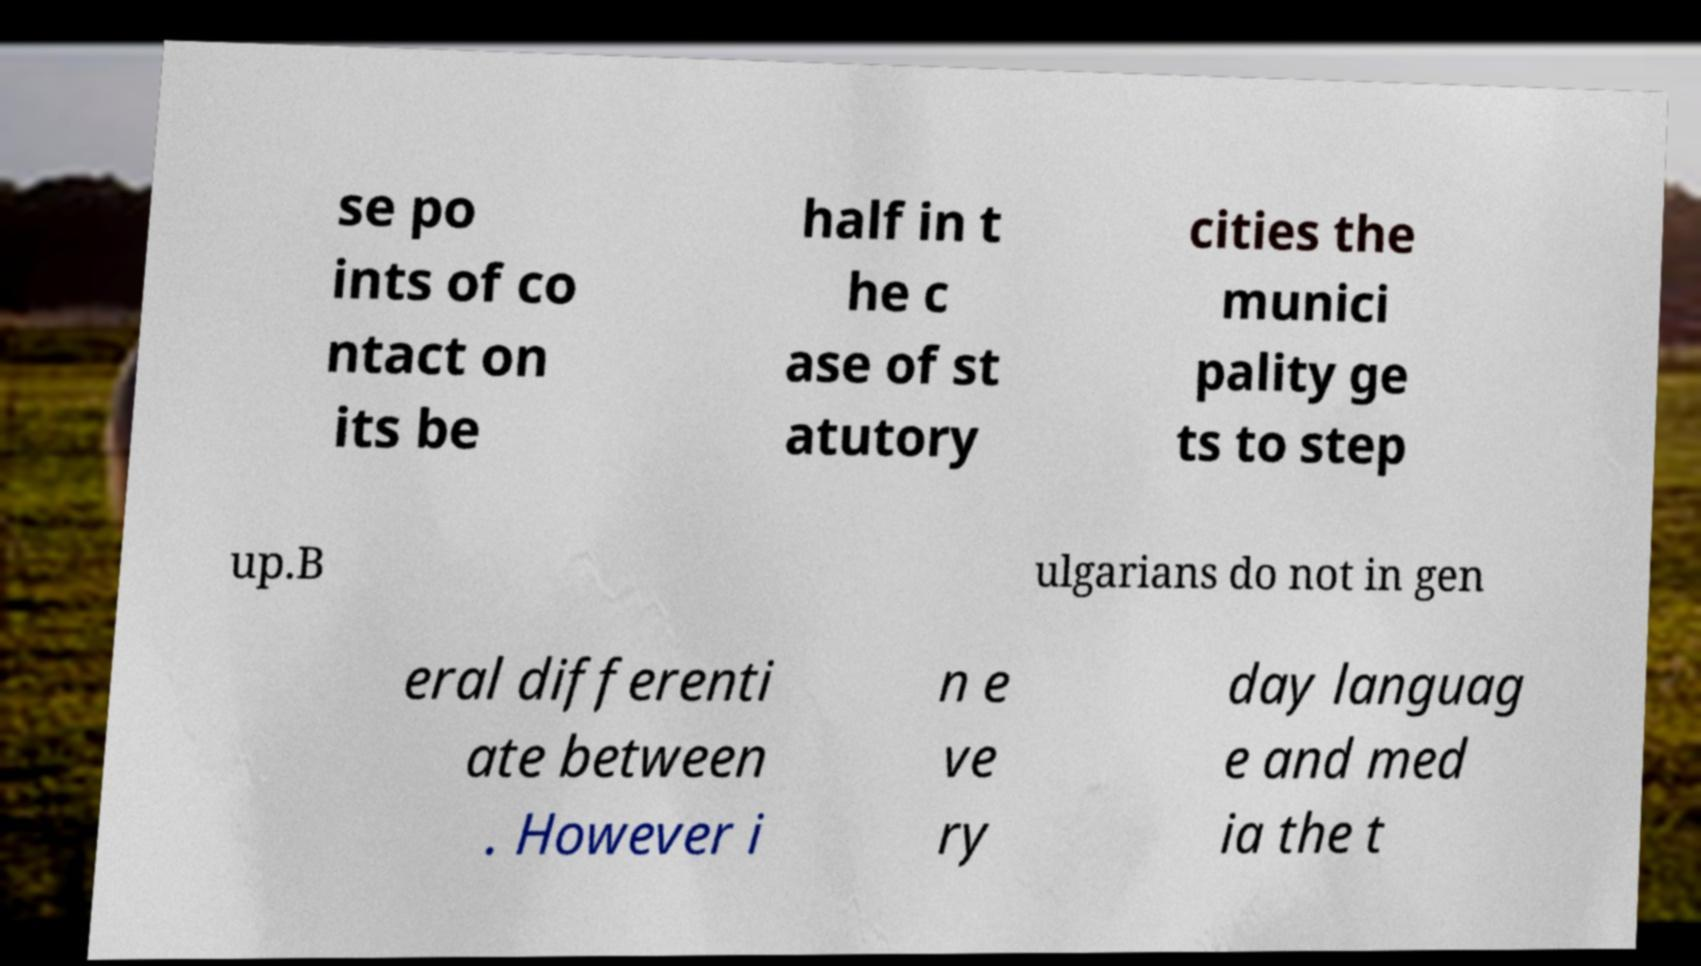For documentation purposes, I need the text within this image transcribed. Could you provide that? se po ints of co ntact on its be half in t he c ase of st atutory cities the munici pality ge ts to step up.B ulgarians do not in gen eral differenti ate between . However i n e ve ry day languag e and med ia the t 